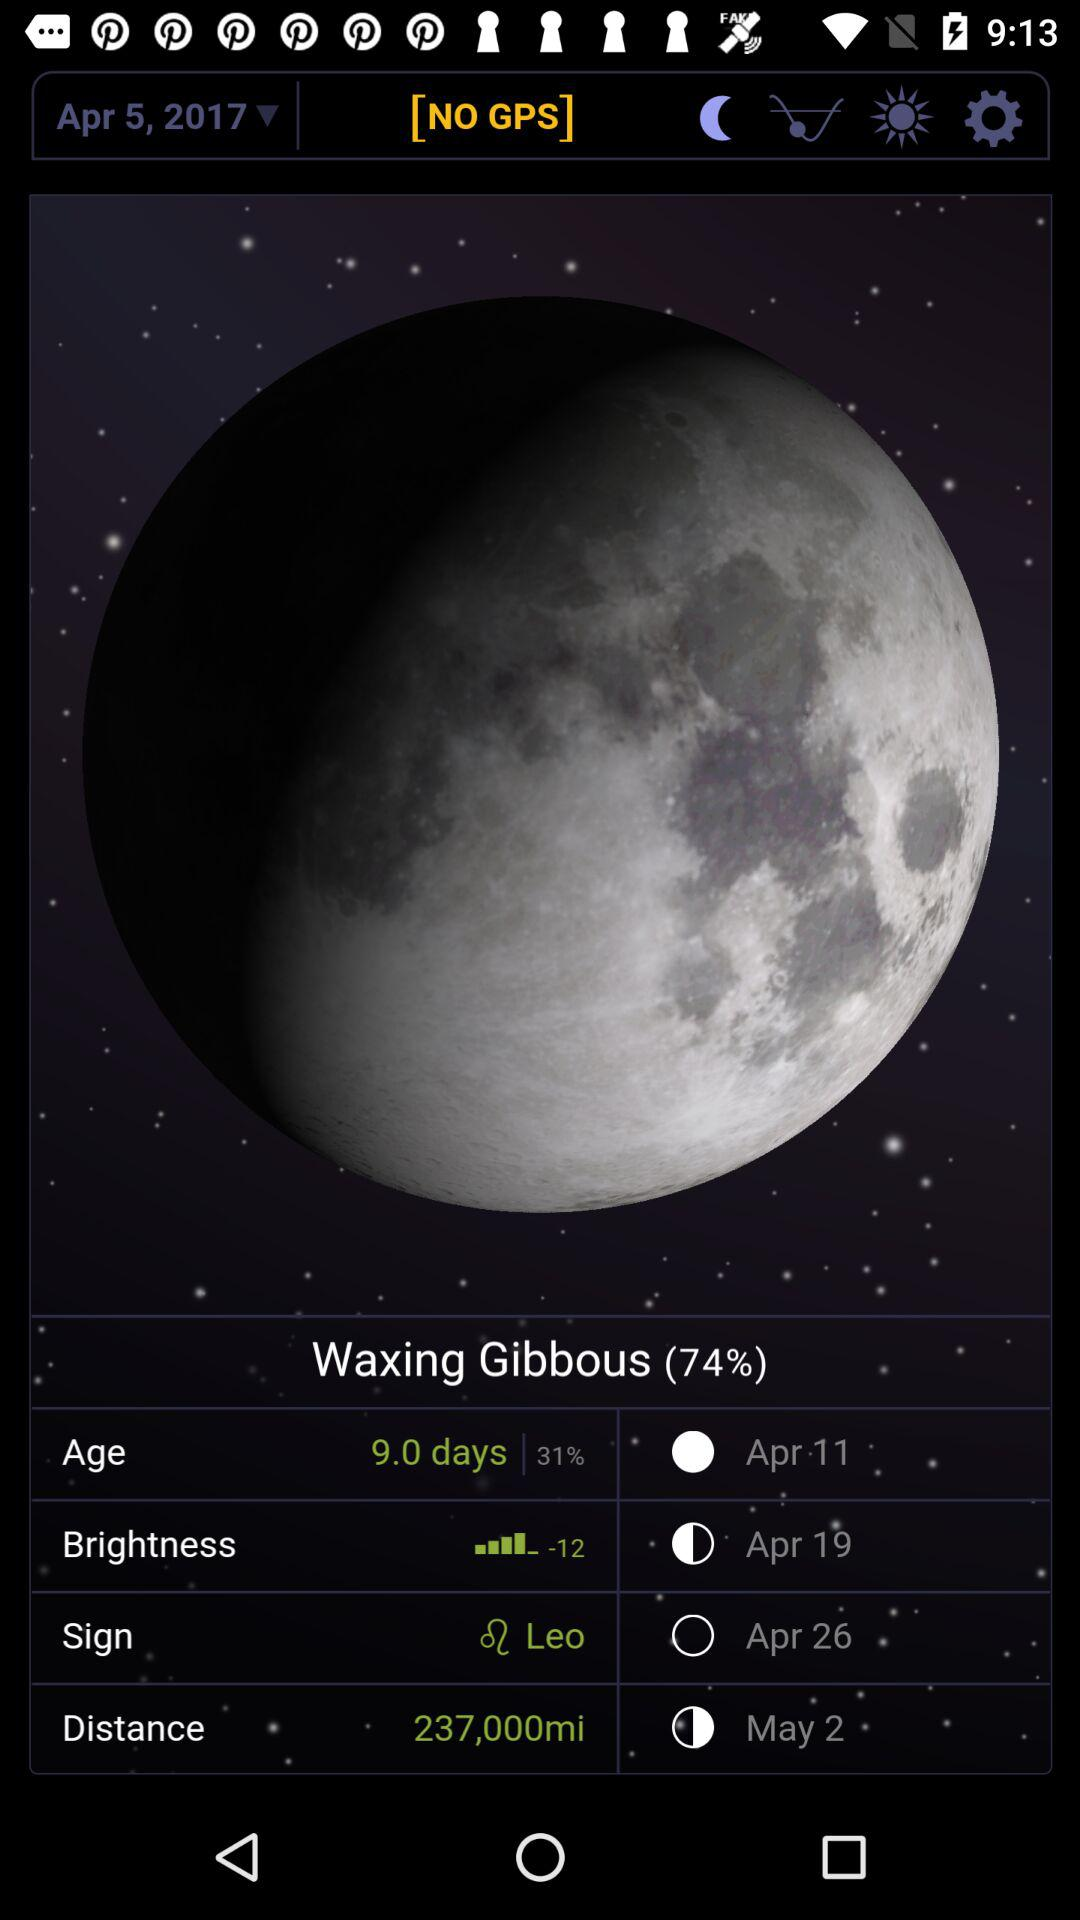What is the brightness number? The brightness number is -12. 